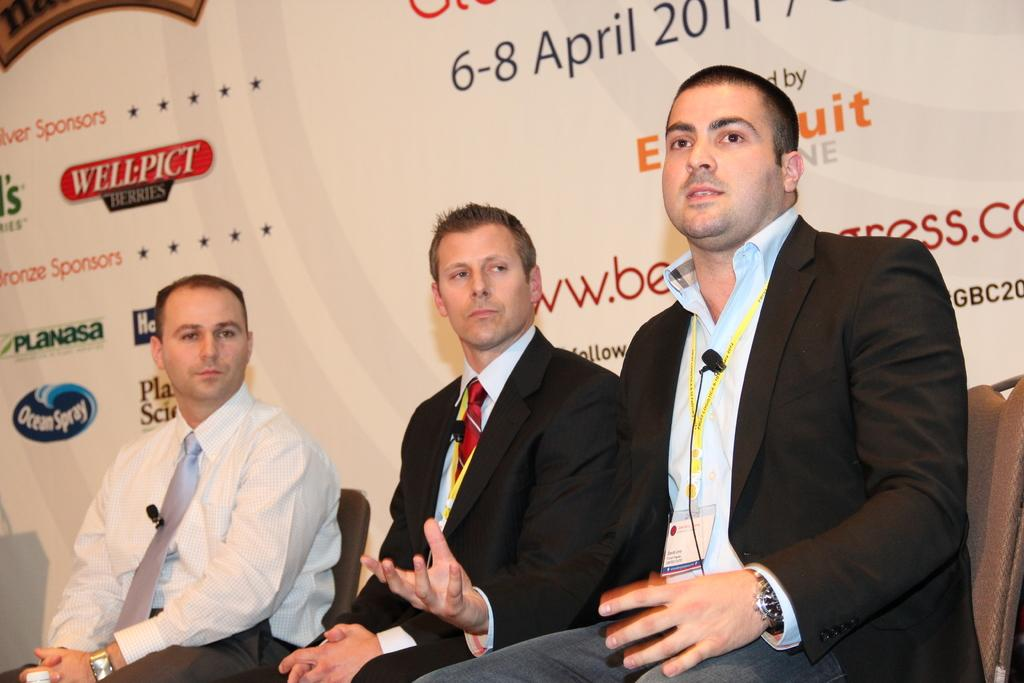What are the people in the center of the image doing? The people in the center of the image are sitting on chairs. What is the person on the right side of the image doing? The person on the right side of the image is talking. What can be seen in the background of the image? There is a banner in the background of the image. How many worms can be seen crawling on the banner in the image? There are no worms present in the image; the banner is visible but does not have any worms on it. 